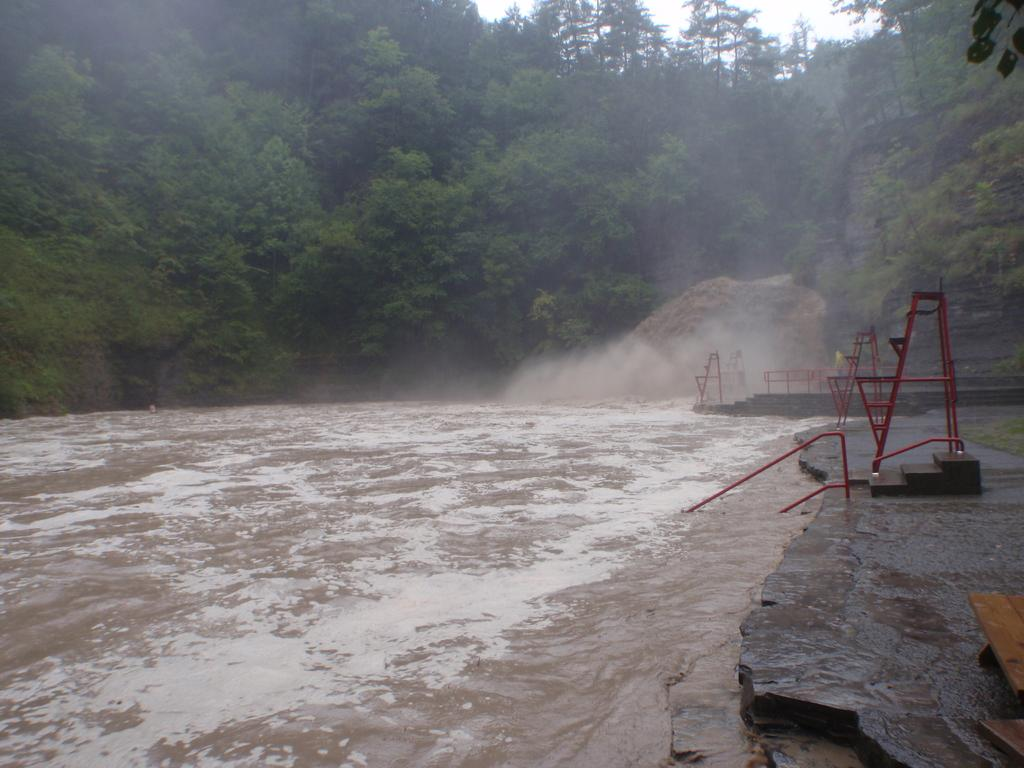What type of body of water is present in the image? There is a lake in the image. What structures can be seen near the lake? Red color stands are visible in the image. What type of natural elements are present in the image? Stones and trees are present in the image. What objects can be seen on the right side of the image? Wooden objects are present on the right side of the image. What is visible at the top of the image? The sky is visible at the top of the image. What type of trousers is the zebra wearing in the image? There is no zebra present in the image, and therefore no trousers to be worn. What type of powder is being used to enhance the color of the wooden objects in the image? There is no mention of powder being used to enhance the color of the wooden objects in the image. 